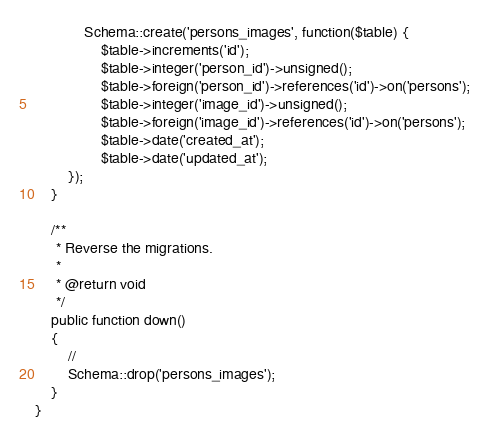<code> <loc_0><loc_0><loc_500><loc_500><_PHP_>            Schema::create('persons_images', function($table) {
                $table->increments('id');
                $table->integer('person_id')->unsigned();
                $table->foreign('person_id')->references('id')->on('persons');
                $table->integer('image_id')->unsigned();
                $table->foreign('image_id')->references('id')->on('persons');
                $table->date('created_at');
                $table->date('updated_at');
        });
    }

    /**
     * Reverse the migrations.
     *
     * @return void
     */
    public function down()
    {
        //
        Schema::drop('persons_images');
    }
}
</code> 